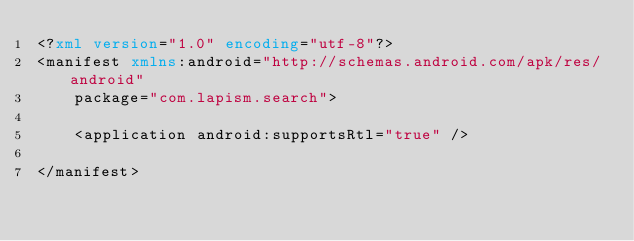<code> <loc_0><loc_0><loc_500><loc_500><_XML_><?xml version="1.0" encoding="utf-8"?>
<manifest xmlns:android="http://schemas.android.com/apk/res/android"
    package="com.lapism.search">

    <application android:supportsRtl="true" />

</manifest></code> 